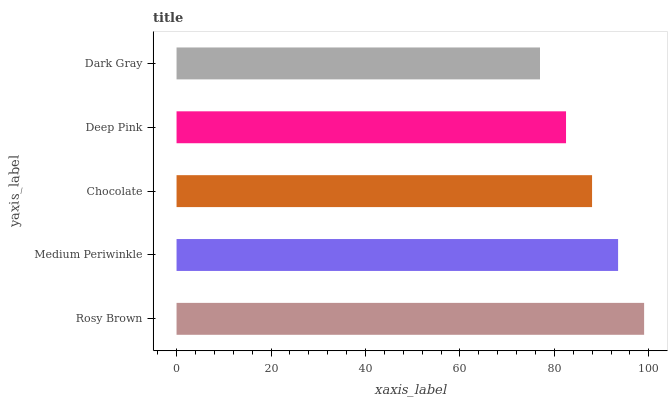Is Dark Gray the minimum?
Answer yes or no. Yes. Is Rosy Brown the maximum?
Answer yes or no. Yes. Is Medium Periwinkle the minimum?
Answer yes or no. No. Is Medium Periwinkle the maximum?
Answer yes or no. No. Is Rosy Brown greater than Medium Periwinkle?
Answer yes or no. Yes. Is Medium Periwinkle less than Rosy Brown?
Answer yes or no. Yes. Is Medium Periwinkle greater than Rosy Brown?
Answer yes or no. No. Is Rosy Brown less than Medium Periwinkle?
Answer yes or no. No. Is Chocolate the high median?
Answer yes or no. Yes. Is Chocolate the low median?
Answer yes or no. Yes. Is Medium Periwinkle the high median?
Answer yes or no. No. Is Dark Gray the low median?
Answer yes or no. No. 